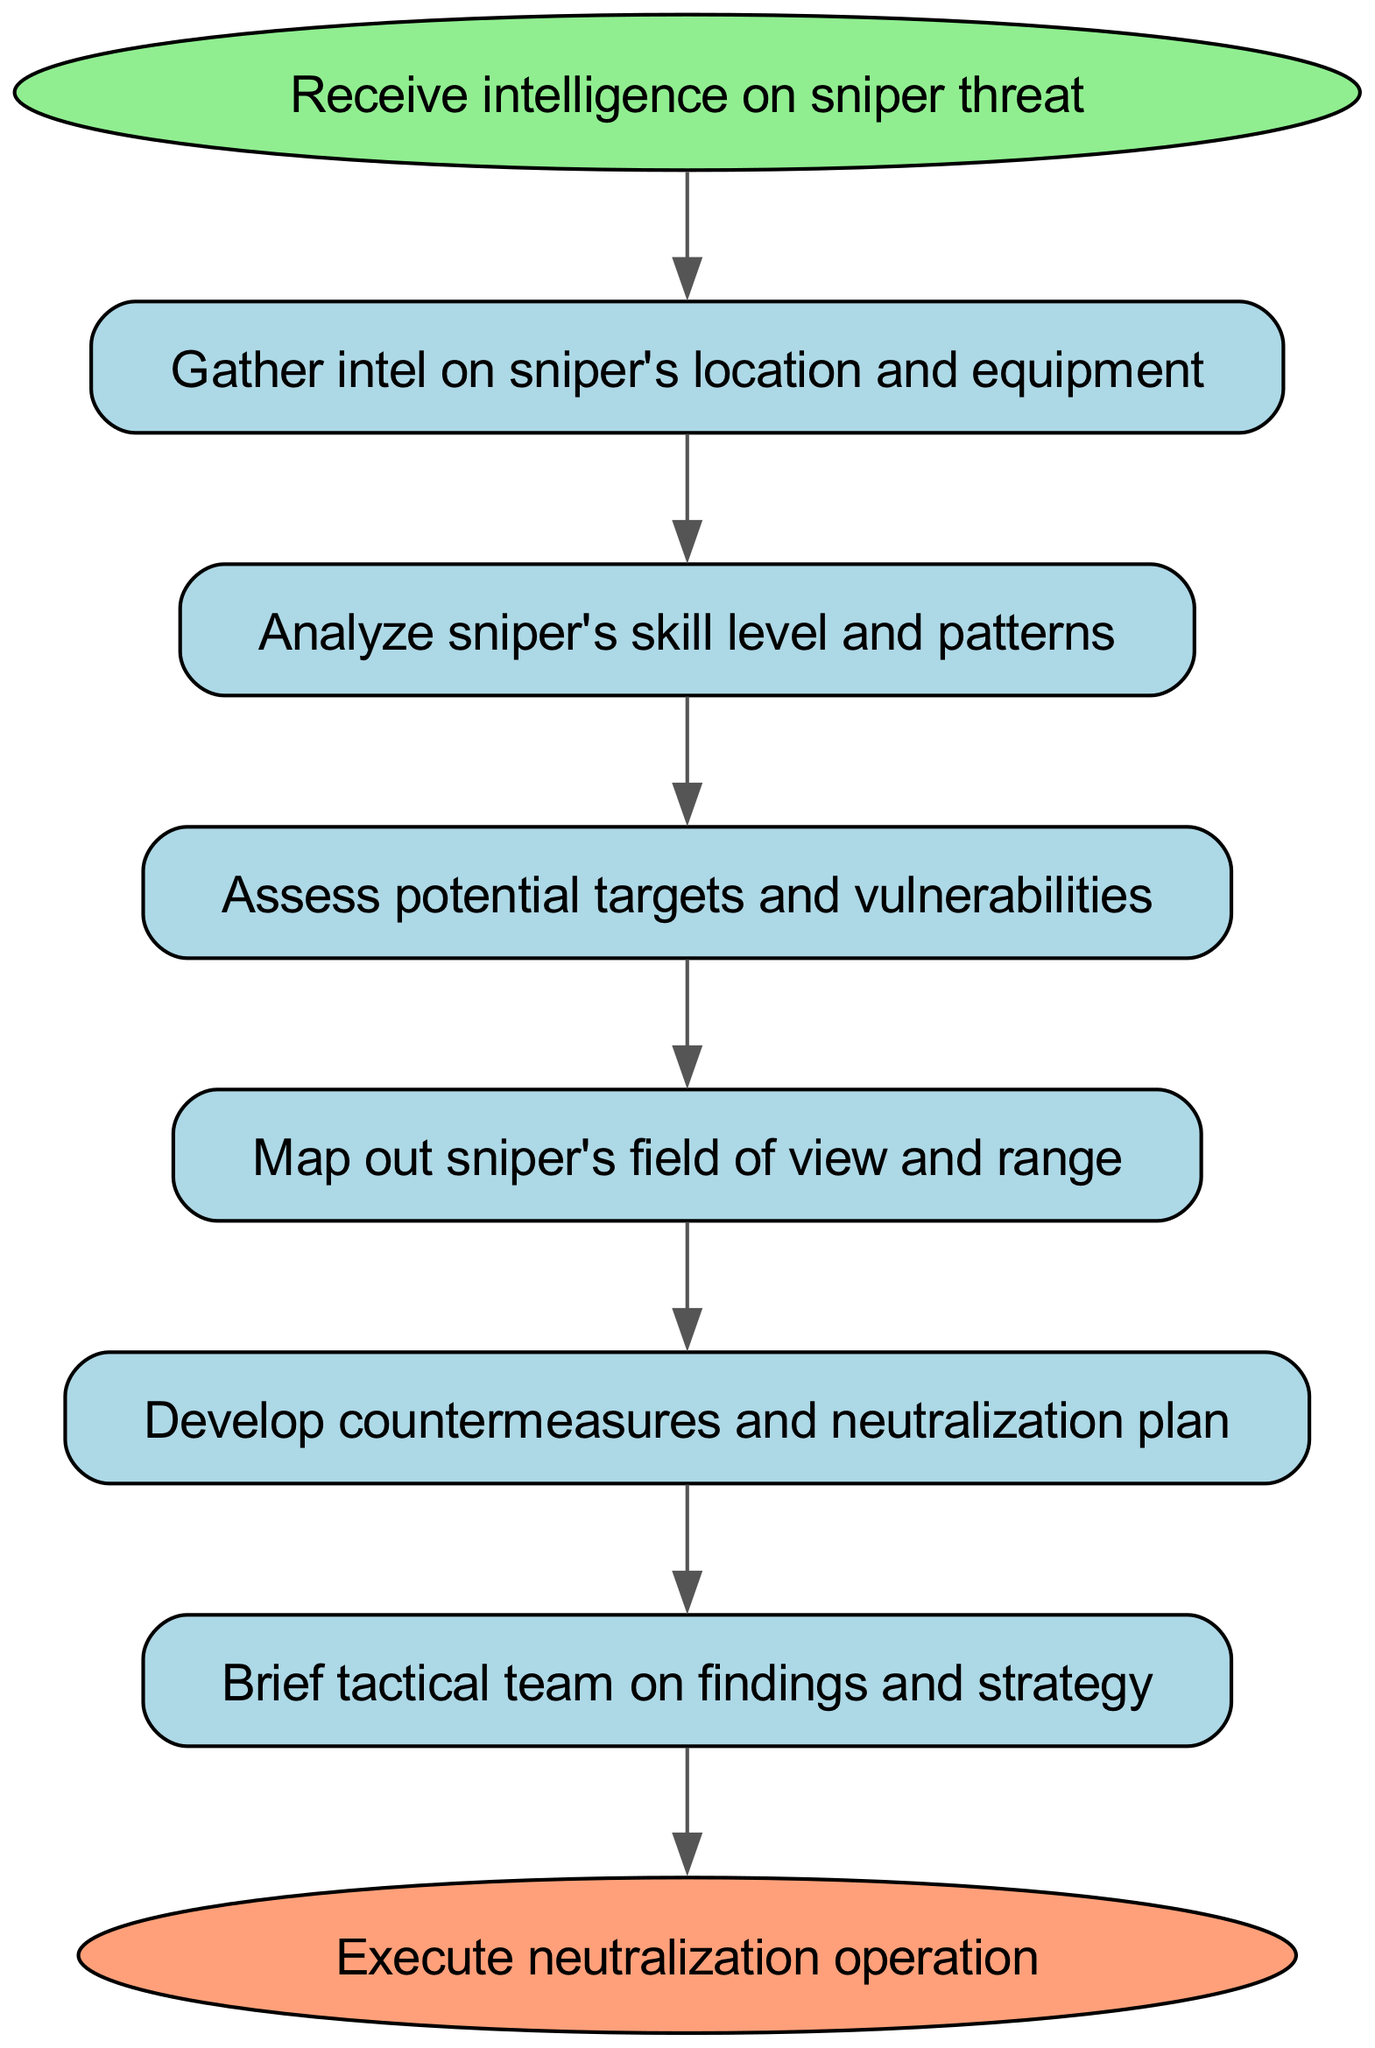What is the first step in the workflow? The first step is labeled "Receive intelligence on sniper threat," which is the starting point of the diagram.
Answer: Receive intelligence on sniper threat How many steps are in the workflow? By counting the nodes in the diagram, I identify a total of eight steps that include both the starting and ending nodes.
Answer: Eight Which step directly follows analyzing the sniper's skill level? The flow indicates that after "Analyze sniper's skill level and patterns," the next step is "Assess potential targets and vulnerabilities."
Answer: Assess potential targets and vulnerabilities What step is taken after mapping the sniper's field of view? Following the "Map out sniper's field of view and range," the next step is "Develop countermeasures and neutralization plan."
Answer: Develop countermeasures and neutralization plan What color represents the ending node in the diagram? The ending node is labeled "Execute neutralization operation," which is represented in a light coral color (FFA07A).
Answer: Light coral What is the relationship between gathering intel and analyzing? The diagram shows a directed edge from "Gather intel on sniper's location and equipment" to "Analyze sniper's skill level and patterns," indicating that gathering intel leads to analysis.
Answer: Gather leads to analyze What node indicates the culmination of the workflow? The final node, indicated as "Execute neutralization operation," signifies the conclusion or culmination of the entire workflow.
Answer: Execute neutralization operation What step comes before briefing the tactical team? The step immediately preceding "Brief tactical team on findings and strategy" is "Develop countermeasures and neutralization plan."
Answer: Develop countermeasures and neutralization plan 